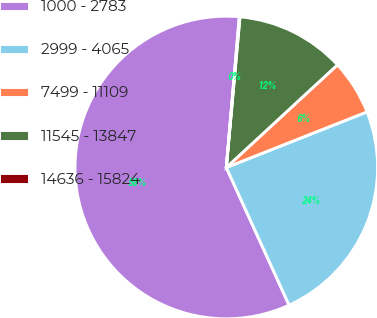Convert chart. <chart><loc_0><loc_0><loc_500><loc_500><pie_chart><fcel>1000 - 2783<fcel>2999 - 4065<fcel>7499 - 11109<fcel>11545 - 13847<fcel>14636 - 15824<nl><fcel>58.18%<fcel>24.18%<fcel>5.88%<fcel>11.69%<fcel>0.07%<nl></chart> 